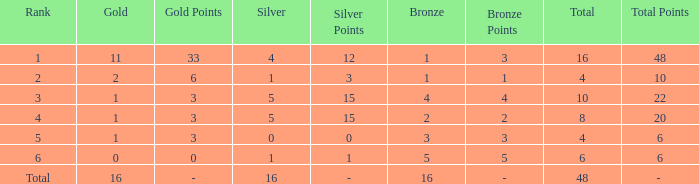What is the total gold that has bronze less than 2, a silver of 1 and total more than 4? None. 